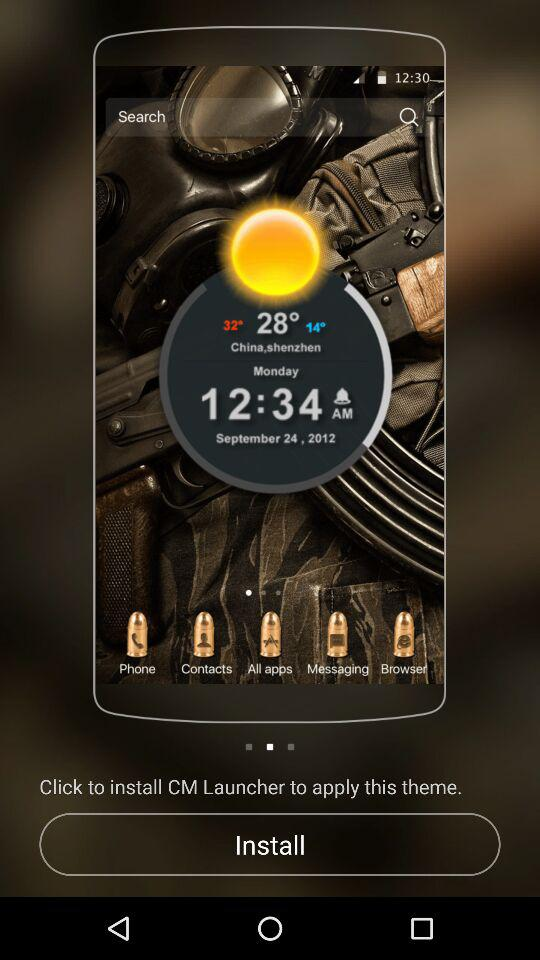What is the set alarm time? The set alarm time is 12:34 AM. 